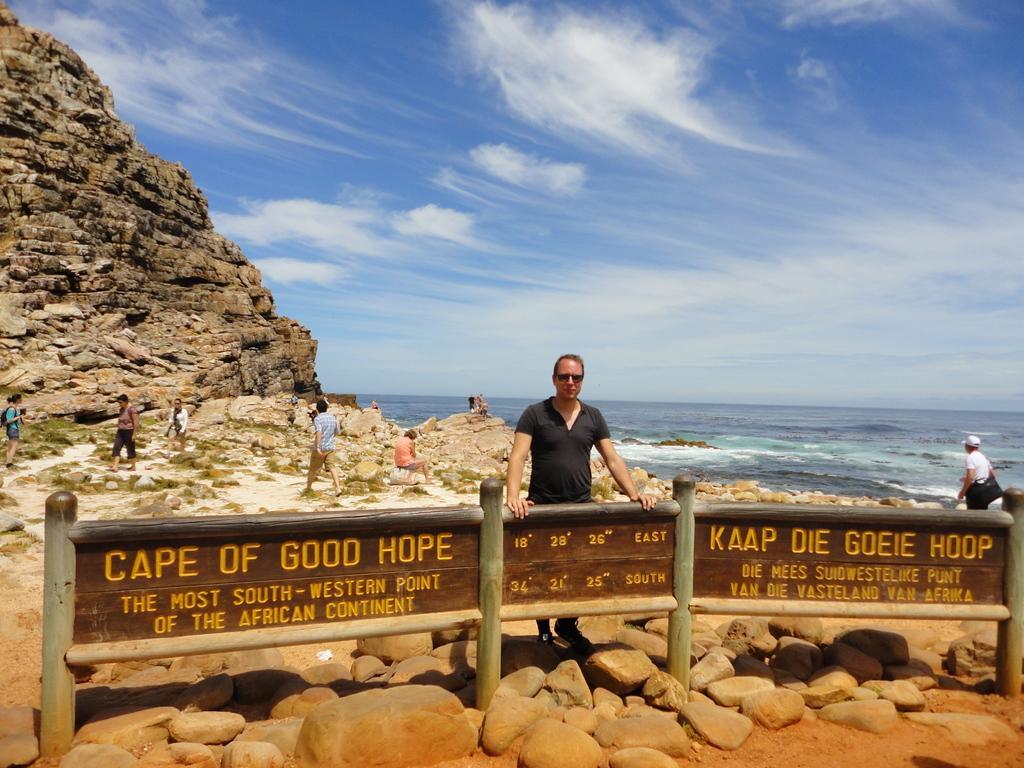In one or two sentences, can you explain what this image depicts? There is a man standing in front of a boundary and stones in the foreground area of the image, there are people, stones, water, it seems like a hill and the sky in the background. 